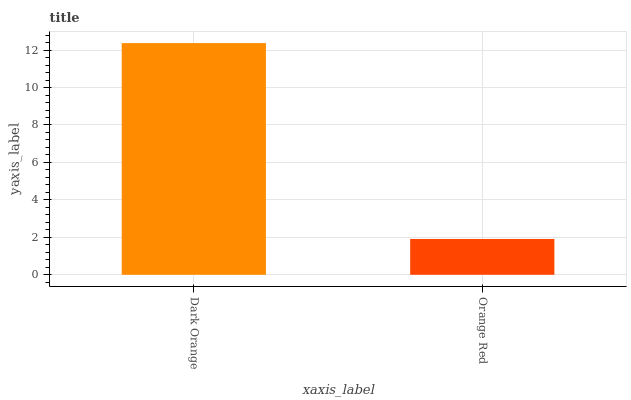Is Orange Red the minimum?
Answer yes or no. Yes. Is Dark Orange the maximum?
Answer yes or no. Yes. Is Orange Red the maximum?
Answer yes or no. No. Is Dark Orange greater than Orange Red?
Answer yes or no. Yes. Is Orange Red less than Dark Orange?
Answer yes or no. Yes. Is Orange Red greater than Dark Orange?
Answer yes or no. No. Is Dark Orange less than Orange Red?
Answer yes or no. No. Is Dark Orange the high median?
Answer yes or no. Yes. Is Orange Red the low median?
Answer yes or no. Yes. Is Orange Red the high median?
Answer yes or no. No. Is Dark Orange the low median?
Answer yes or no. No. 